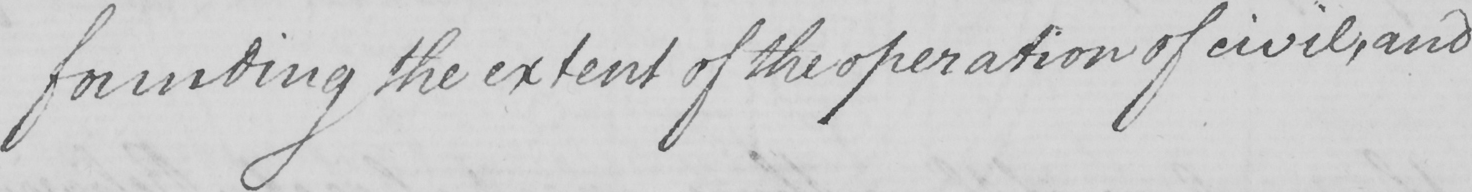Can you tell me what this handwritten text says? -founding the extent of the operation of civil , and 